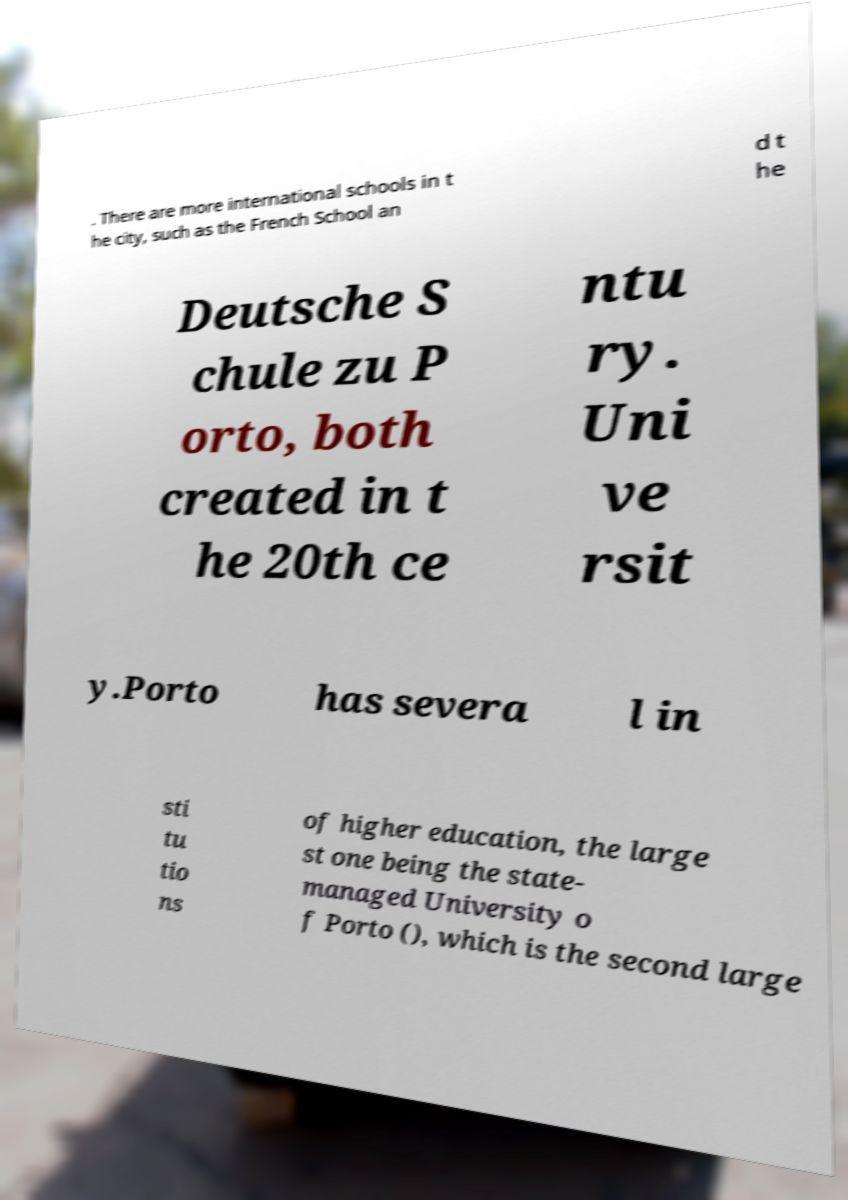Please identify and transcribe the text found in this image. . There are more international schools in t he city, such as the French School an d t he Deutsche S chule zu P orto, both created in t he 20th ce ntu ry. Uni ve rsit y.Porto has severa l in sti tu tio ns of higher education, the large st one being the state- managed University o f Porto (), which is the second large 